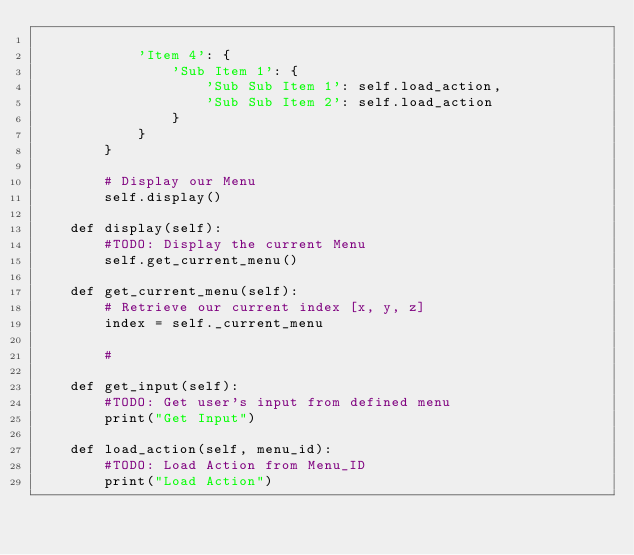Convert code to text. <code><loc_0><loc_0><loc_500><loc_500><_Python_>
            'Item 4': {
                'Sub Item 1': {
                    'Sub Sub Item 1': self.load_action,
                    'Sub Sub Item 2': self.load_action
                }
            }
        }

        # Display our Menu
        self.display()

    def display(self):
        #TODO: Display the current Menu
        self.get_current_menu()

    def get_current_menu(self):
        # Retrieve our current index [x, y, z]
        index = self._current_menu

        # 

    def get_input(self):
        #TODO: Get user's input from defined menu
        print("Get Input")

    def load_action(self, menu_id):
        #TODO: Load Action from Menu_ID
        print("Load Action")</code> 